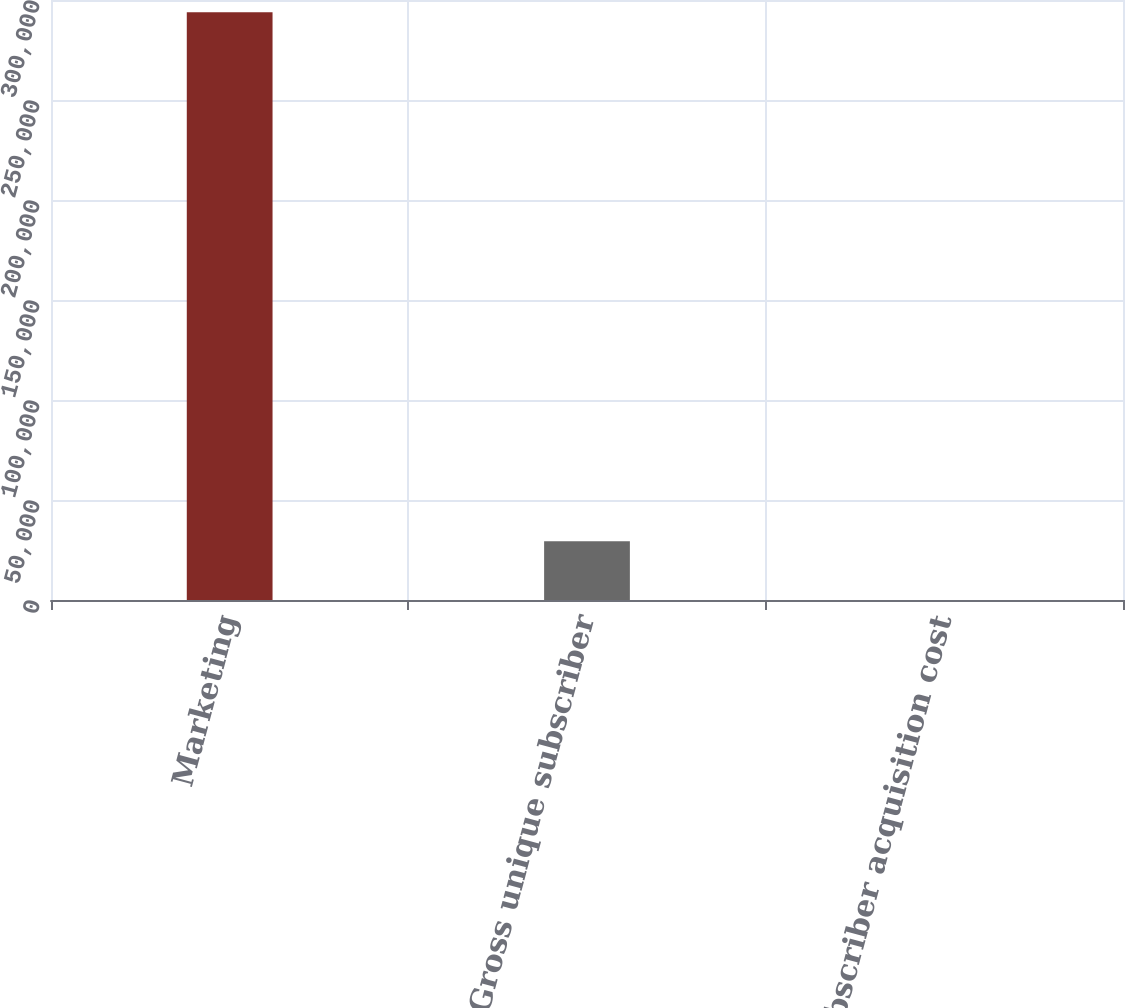Convert chart. <chart><loc_0><loc_0><loc_500><loc_500><bar_chart><fcel>Marketing<fcel>Gross unique subscriber<fcel>Subscriber acquisition cost<nl><fcel>293839<fcel>29400.3<fcel>18.21<nl></chart> 